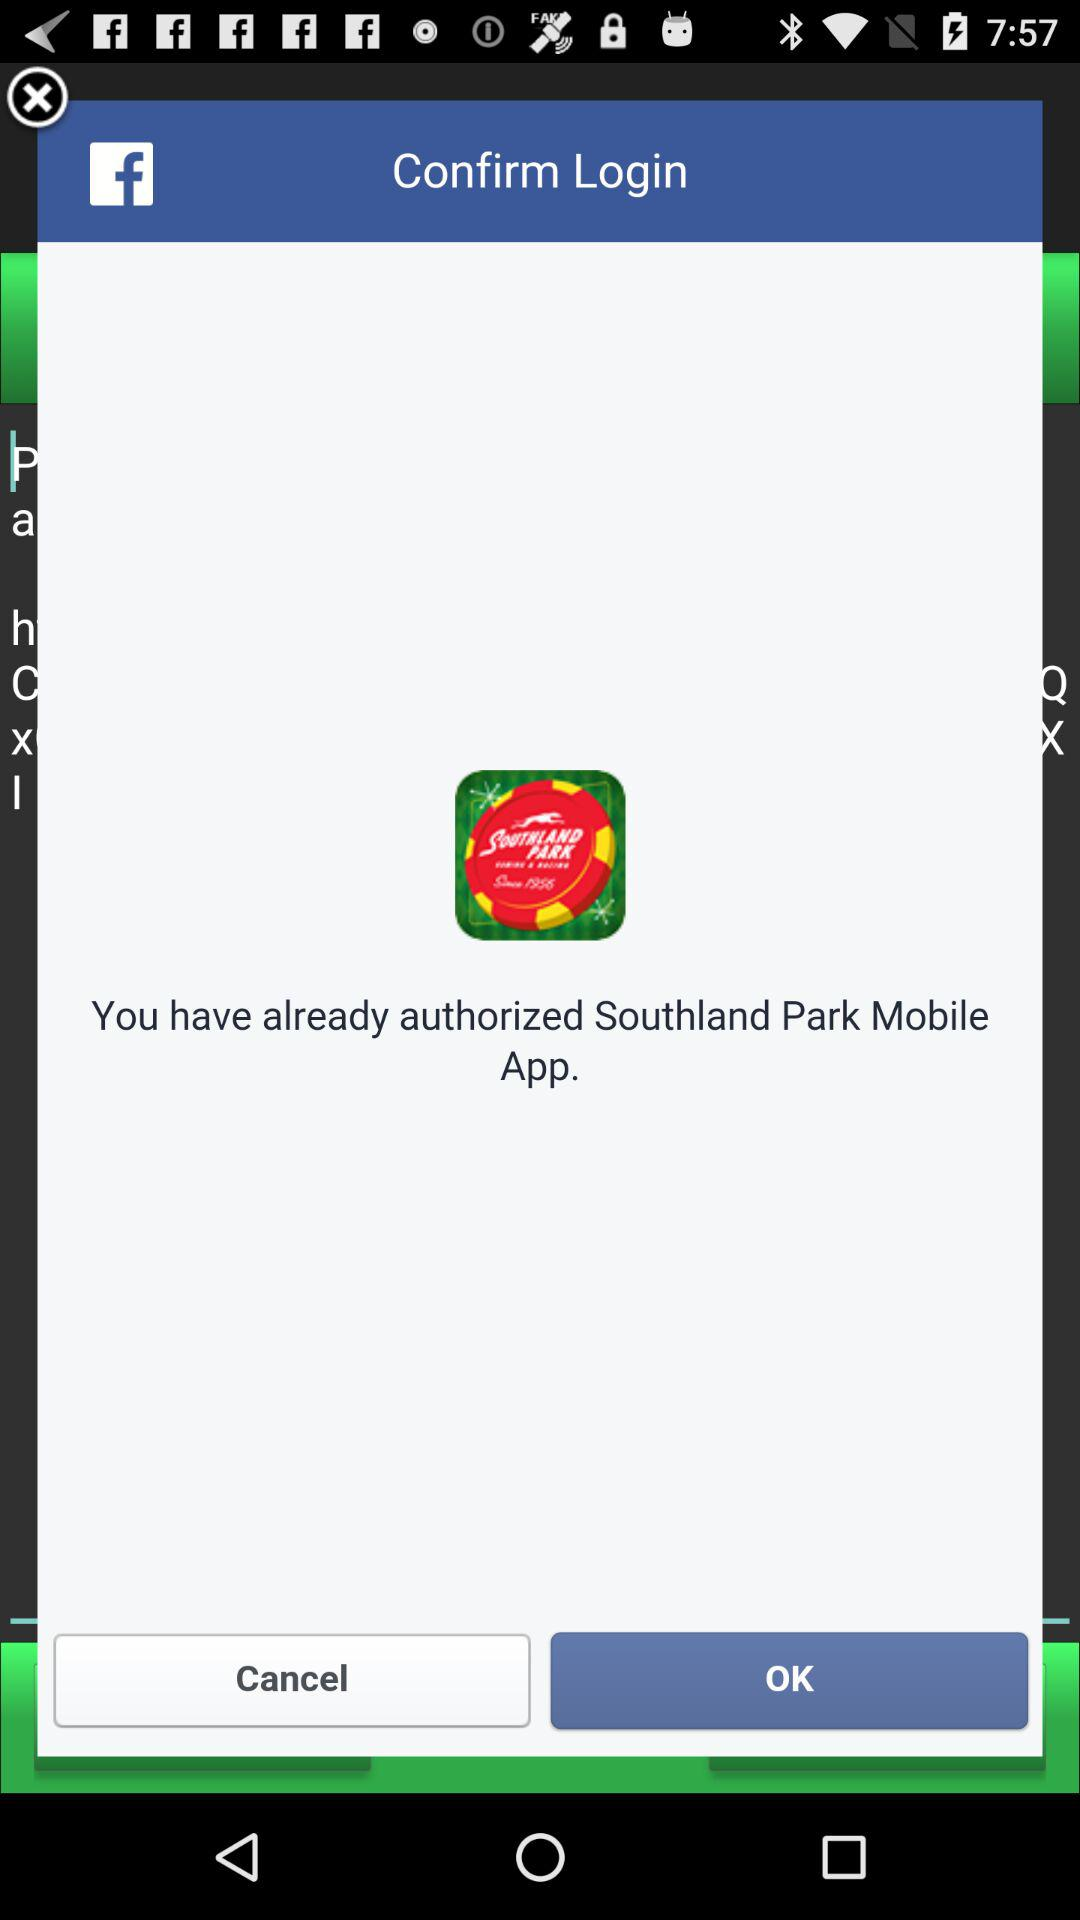What application is the user accessing? The user is accessing the "Southland Park" application. 